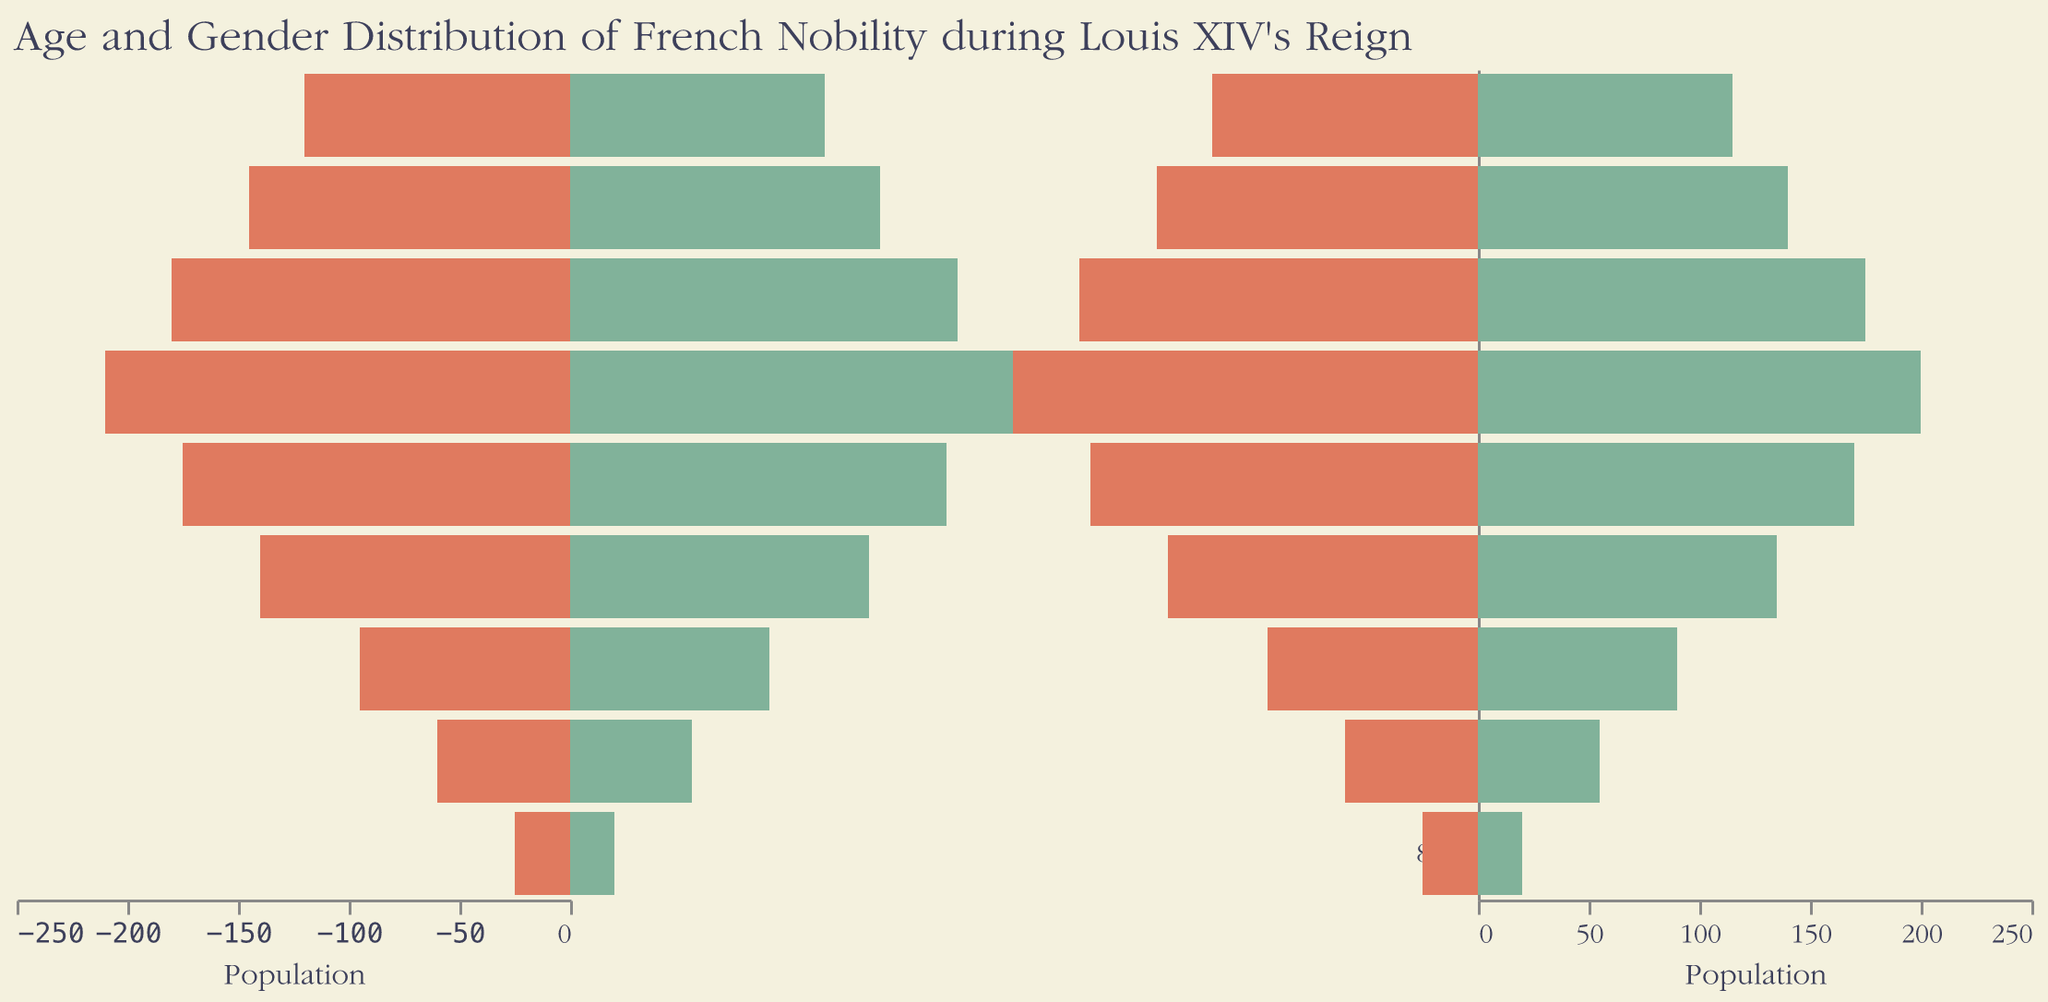what is the title of the figure? The title is located at the top of the figure and describes the figure's content.
Answer: Age and Gender Distribution of French Nobility during Louis XIV's Reign which gender had a larger population in the age group 30-39? By comparing the bar lengths for males and females in the 30-39 age group, the male bar is longer.
Answer: Male what is the age group with the highest female population? Look at the female bars and identify the one that extends the furthest to the right.
Answer: 30-39 calculate the total population for the age group 10-19? Sum the number of males and females in the 10-19 age group (145 + 140).
Answer: 285 how does the male population in the 50-59 age group compare to the female population in the same age group? Compare the bar lengths for males and females in the 50-59 age group. The male bar is slightly longer than the female bar.
Answer: Greater which age group has the least number of males? Look for the shortest male bar on the left side of the pyramid.
Answer: 80+ is the population pyramid symmetric and what does that indicate about the gender distribution? Symmetric pyramids indicate an equal distribution of males and females. This pyramid is mostly symmetric with slight differences in older age groups, suggesting a fairly balanced gender ratio with small variations.
Answer: Mostly symmetric 